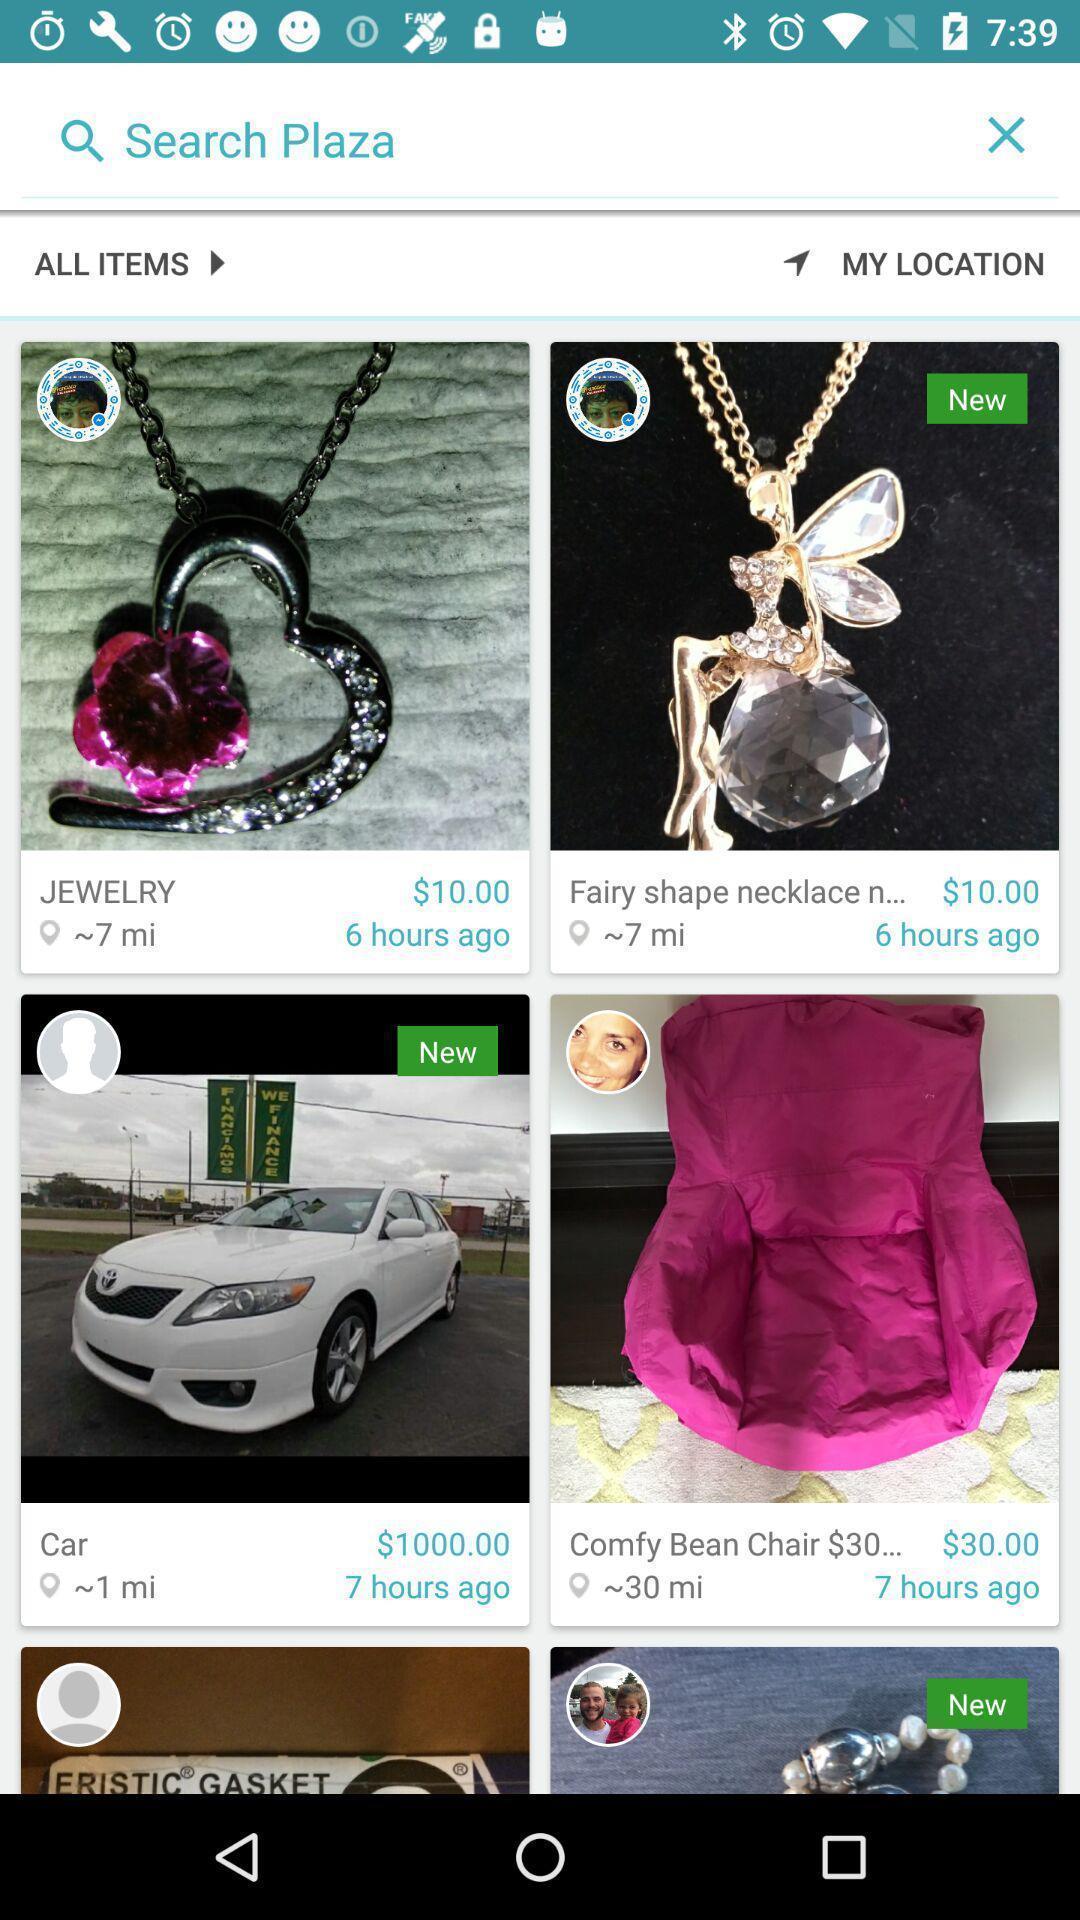Explain what's happening in this screen capture. Search option to find number of products. 